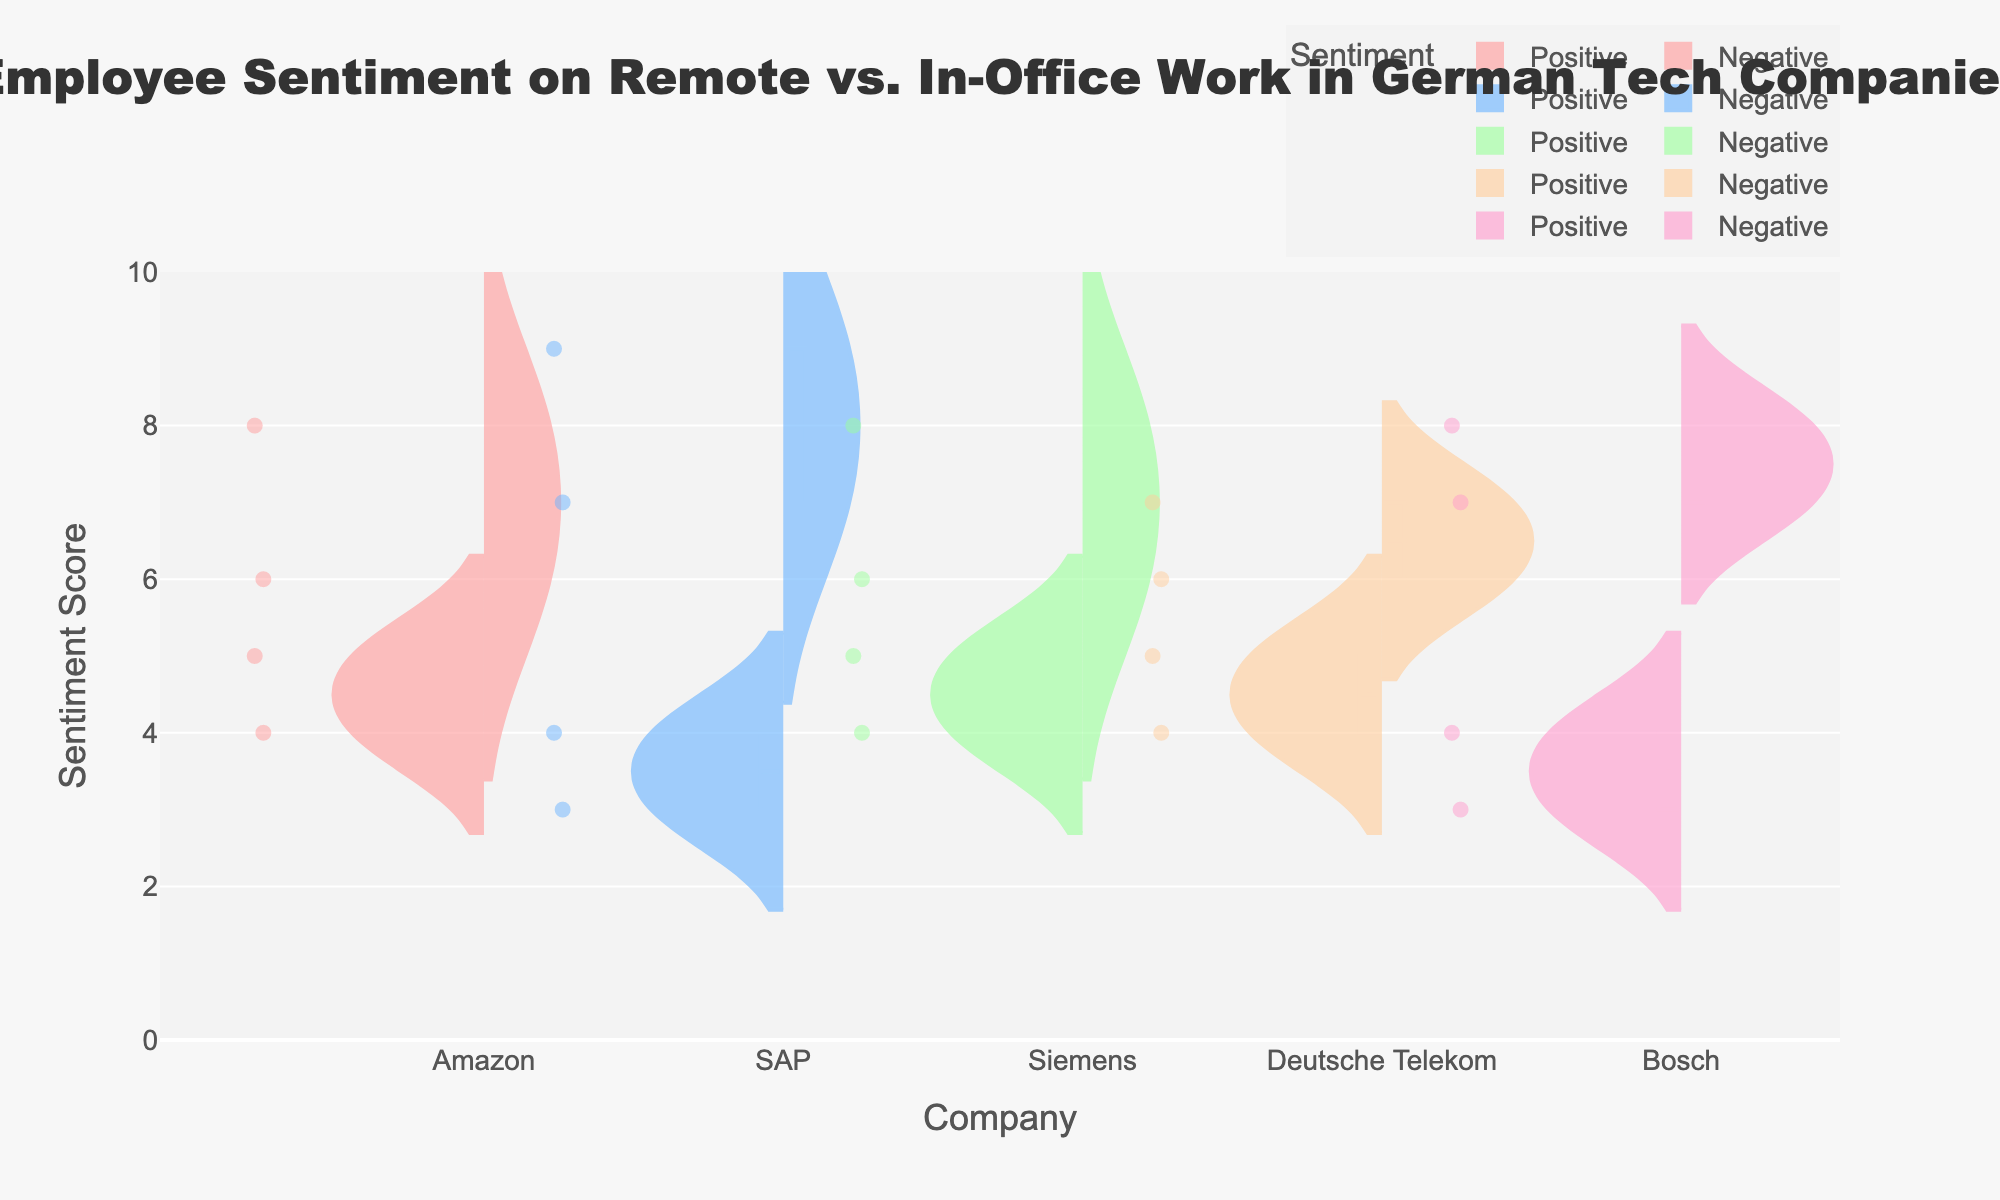What is the title of the figure? The title is usually found at the top of the figure and gives a summary of what the visualization is about. Here, we see the title "Employee Sentiment on Remote vs. In-Office Work in German Tech Companies".
Answer: Employee Sentiment on Remote vs. In-Office Work in German Tech Companies Which company has the highest sentiment score for remote work? To answer this, look at the upper end of the violin plots on the positive side for remote work and identify the highest score. SAP has a positive score of 9 for remote work, which is the highest.
Answer: SAP How does Amazon's negative sentiment for remote work compare to in-office work? Compare the negative sides of the violin plots for both remote and in-office work for Amazon. The negative sentiment scores for remote work are clustered around 4, whereas for in-office work they are around 5.
Answer: Lower for remote work Which company shows the smallest difference between positive sentiment scores for remote and in-office work? Consider the positive sentiment scores for both remote and in-office work for each company. The smallest difference is for Deutsche Telekom, where the scores are 7 (remote) and 6 (in-office).
Answer: Deutsche Telekom What is the common range of sentiment scores for Siemens' negative sentiment on remote work? Examine the lower half of the violin plot for Siemens' negative sentiment on remote work to see the spread and common range of sentiment. The scores are around 5, indicating a narrow range.
Answer: 5 Which colors represent Amazon and SAP in the figure? Identify the colors used in the violin plots for Amazon and SAP. Amazon is represented using the first color, a light red hue, and SAP is represented using the second color, a light blue hue.
Answer: Light red for Amazon, light blue for SAP Is there a company where employees prefer remote work unanimously (all positive sentiments)? Check if any company’s violin plot shows positive sentiment predominantly for remote work without any negative scores. None of the companies show unanimous positive sentiment for remote work.
Answer: No What is the average score of positive sentiment for Bosch's remote work? Bosch has positive sentiment scores of 8 for remote work according to the data. Since there's only one data point on the positive side, the average score is 8.
Answer: 8 